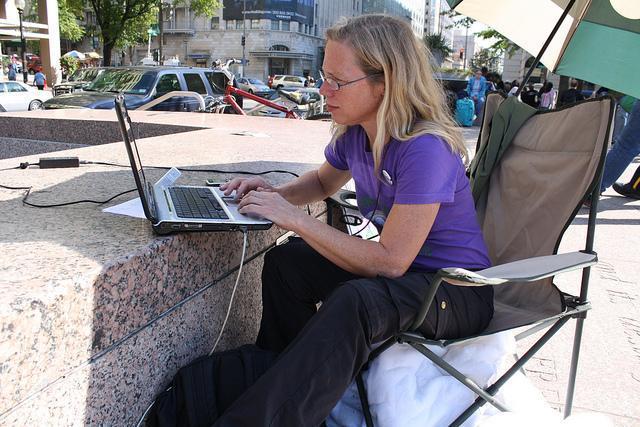How many people are visible?
Give a very brief answer. 2. 